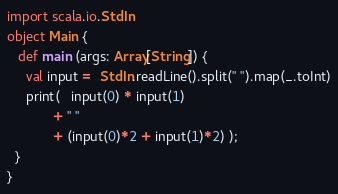Convert code to text. <code><loc_0><loc_0><loc_500><loc_500><_Scala_>import scala.io.StdIn
object Main {
   def main (args: Array[String]) {
     val input =  StdIn.readLine().split(" ").map(_.toInt)
     print(   input(0) * input(1)
            + " "
            + (input(0)*2 + input(1)*2) );
  }
}</code> 